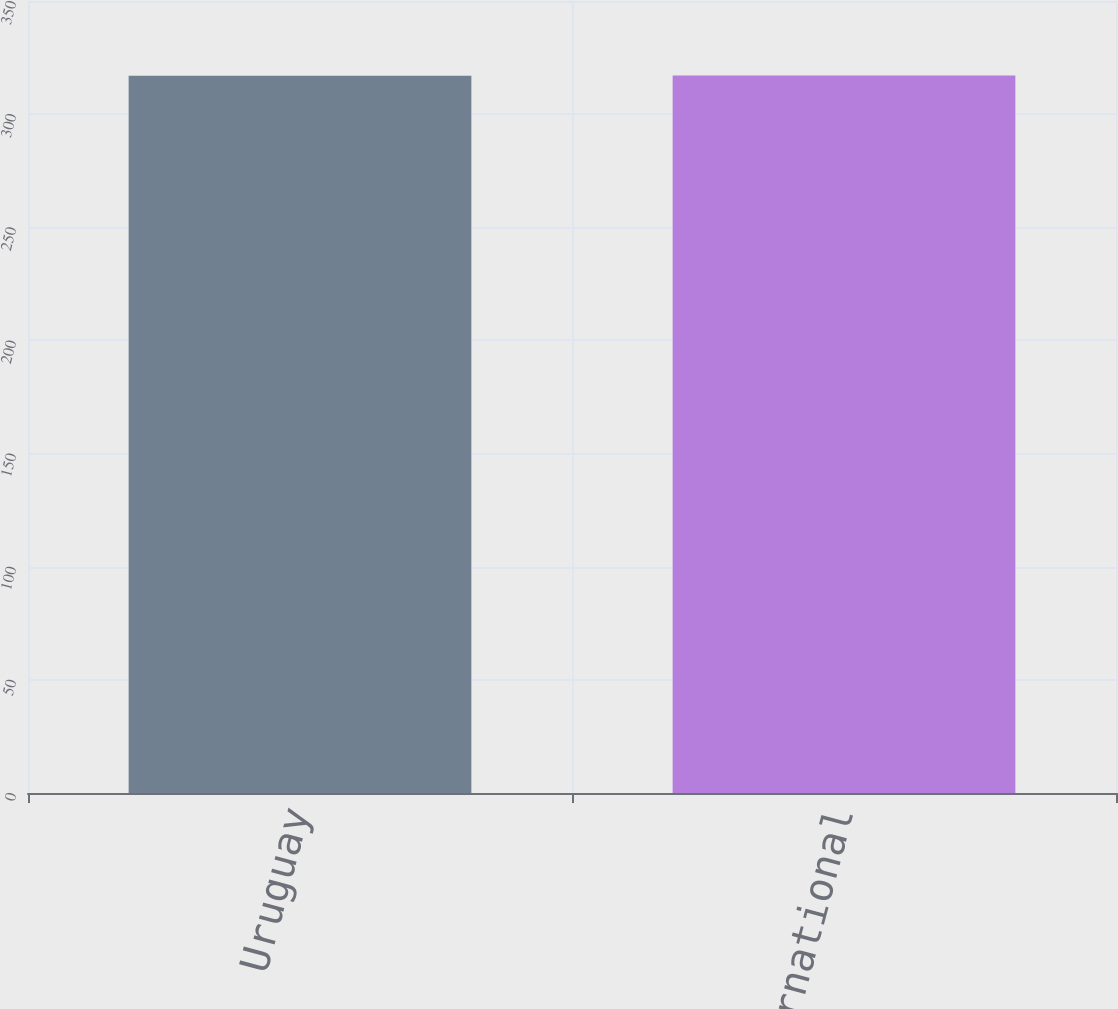Convert chart to OTSL. <chart><loc_0><loc_0><loc_500><loc_500><bar_chart><fcel>Uruguay<fcel>Total International<nl><fcel>317<fcel>317.1<nl></chart> 